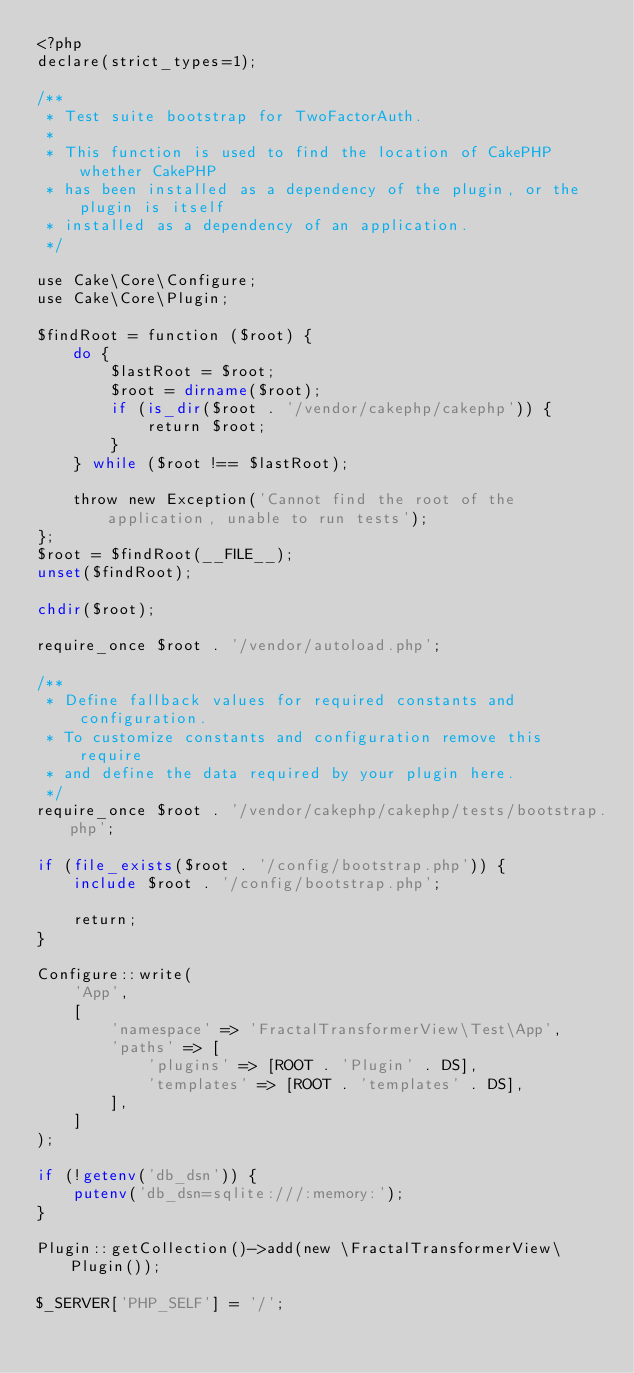Convert code to text. <code><loc_0><loc_0><loc_500><loc_500><_PHP_><?php
declare(strict_types=1);

/**
 * Test suite bootstrap for TwoFactorAuth.
 *
 * This function is used to find the location of CakePHP whether CakePHP
 * has been installed as a dependency of the plugin, or the plugin is itself
 * installed as a dependency of an application.
 */

use Cake\Core\Configure;
use Cake\Core\Plugin;

$findRoot = function ($root) {
    do {
        $lastRoot = $root;
        $root = dirname($root);
        if (is_dir($root . '/vendor/cakephp/cakephp')) {
            return $root;
        }
    } while ($root !== $lastRoot);

    throw new Exception('Cannot find the root of the application, unable to run tests');
};
$root = $findRoot(__FILE__);
unset($findRoot);

chdir($root);

require_once $root . '/vendor/autoload.php';

/**
 * Define fallback values for required constants and configuration.
 * To customize constants and configuration remove this require
 * and define the data required by your plugin here.
 */
require_once $root . '/vendor/cakephp/cakephp/tests/bootstrap.php';

if (file_exists($root . '/config/bootstrap.php')) {
    include $root . '/config/bootstrap.php';

    return;
}

Configure::write(
    'App',
    [
        'namespace' => 'FractalTransformerView\Test\App',
        'paths' => [
            'plugins' => [ROOT . 'Plugin' . DS],
            'templates' => [ROOT . 'templates' . DS],
        ],
    ]
);

if (!getenv('db_dsn')) {
    putenv('db_dsn=sqlite:///:memory:');
}

Plugin::getCollection()->add(new \FractalTransformerView\Plugin());

$_SERVER['PHP_SELF'] = '/';
</code> 